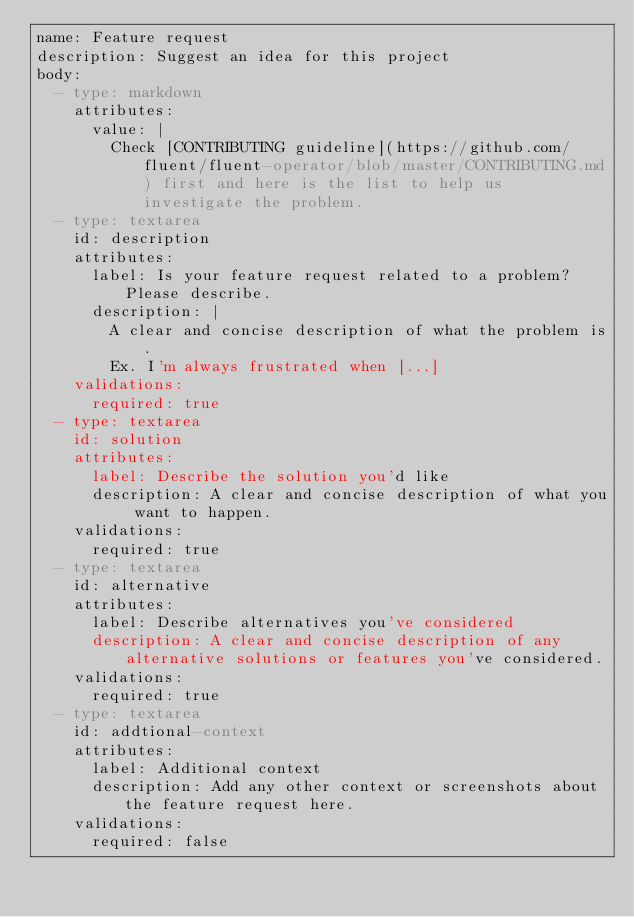<code> <loc_0><loc_0><loc_500><loc_500><_YAML_>name: Feature request
description: Suggest an idea for this project
body:
  - type: markdown
    attributes:
      value: |
        Check [CONTRIBUTING guideline](https://github.com/fluent/fluent-operator/blob/master/CONTRIBUTING.md) first and here is the list to help us investigate the problem.
  - type: textarea
    id: description
    attributes:
      label: Is your feature request related to a problem? Please describe.
      description: |
        A clear and concise description of what the problem is.
        Ex. I'm always frustrated when [...]
    validations:
      required: true
  - type: textarea
    id: solution
    attributes:
      label: Describe the solution you'd like
      description: A clear and concise description of what you want to happen.
    validations:
      required: true
  - type: textarea
    id: alternative
    attributes:
      label: Describe alternatives you've considered
      description: A clear and concise description of any alternative solutions or features you've considered.
    validations:
      required: true
  - type: textarea
    id: addtional-context
    attributes:
      label: Additional context
      description: Add any other context or screenshots about the feature request here.
    validations:
      required: false
</code> 